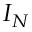Convert formula to latex. <formula><loc_0><loc_0><loc_500><loc_500>I _ { N }</formula> 